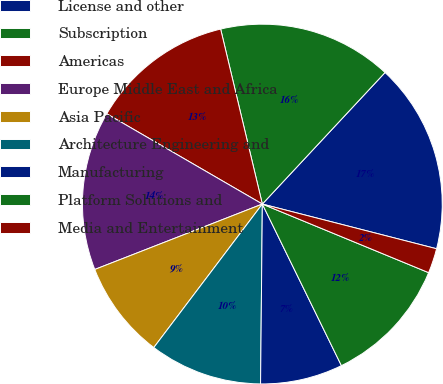<chart> <loc_0><loc_0><loc_500><loc_500><pie_chart><fcel>License and other<fcel>Subscription<fcel>Americas<fcel>Europe Middle East and Africa<fcel>Asia Pacific<fcel>Architecture Engineering and<fcel>Manufacturing<fcel>Platform Solutions and<fcel>Media and Entertainment<nl><fcel>17.05%<fcel>15.67%<fcel>12.91%<fcel>14.29%<fcel>8.77%<fcel>10.15%<fcel>7.4%<fcel>11.53%<fcel>2.23%<nl></chart> 